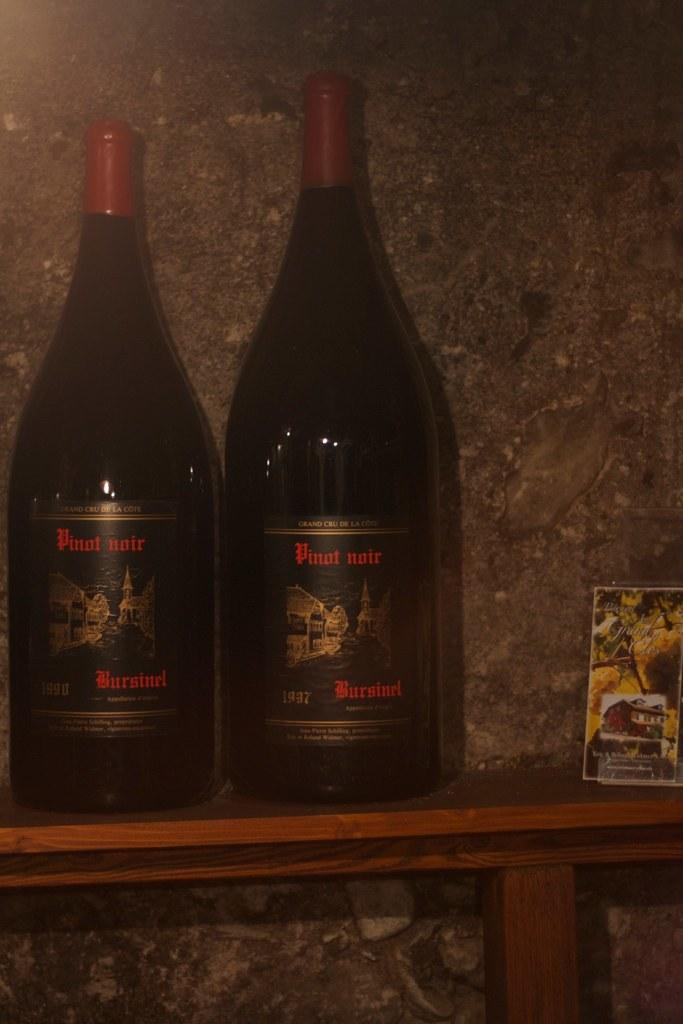<image>
Provide a brief description of the given image. Two bottles of Pinot Noir wine from 1937 on a wood shelf. 